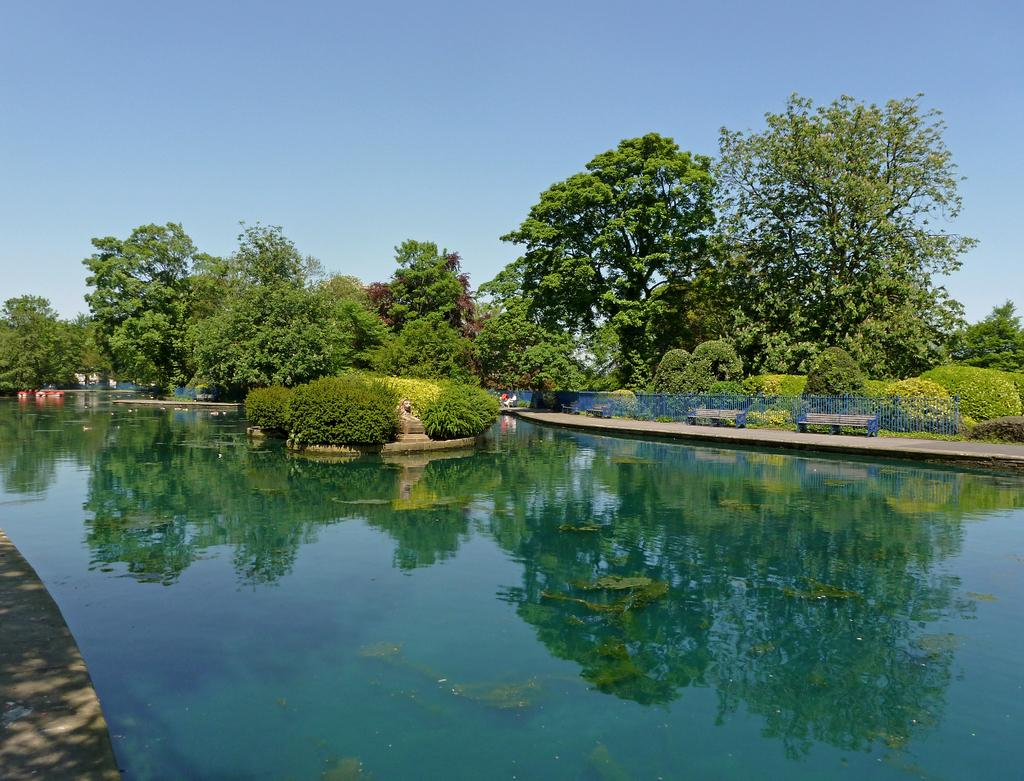What is the main feature in the foreground of the image? There is a water body in the foreground of the image. What can be seen in the middle of the image? There are trees in the middle of the image. What is visible at the top of the image? The sky is visible at the top of the image. Can you tell me how many times the queen appears in the image? There is no queen present in the image. What type of shape is formed by the trees in the image? The trees in the image do not form a specific shape like a circle; they are scattered throughout the middle of the image. 